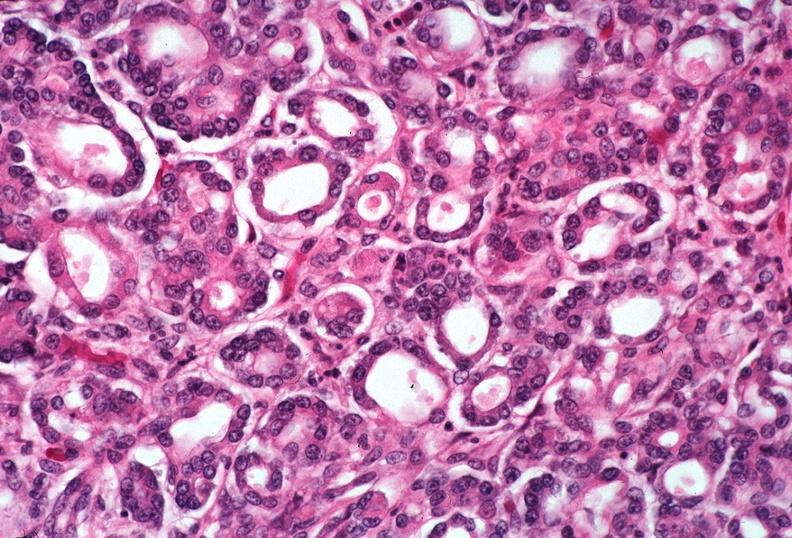does this image show pancreas, uremic pancreatitis due to polycystic kidney?
Answer the question using a single word or phrase. Yes 